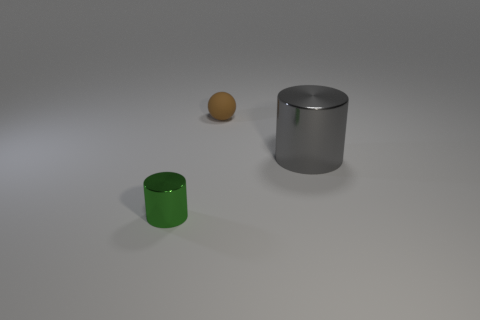Add 1 tiny purple metal cylinders. How many objects exist? 4 Subtract all balls. How many objects are left? 2 Add 3 green objects. How many green objects are left? 4 Add 1 small purple metallic cylinders. How many small purple metallic cylinders exist? 1 Subtract 0 purple cylinders. How many objects are left? 3 Subtract all green cylinders. Subtract all big things. How many objects are left? 1 